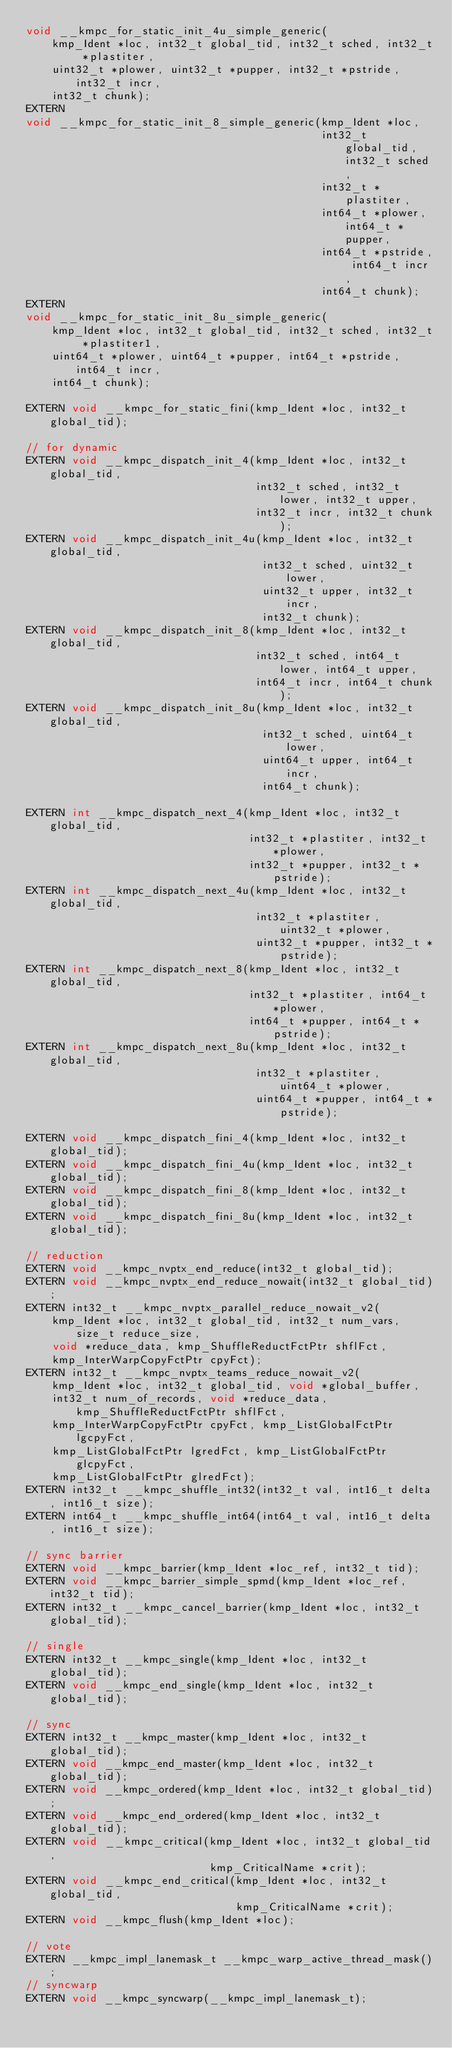<code> <loc_0><loc_0><loc_500><loc_500><_C_>void __kmpc_for_static_init_4u_simple_generic(
    kmp_Ident *loc, int32_t global_tid, int32_t sched, int32_t *plastiter,
    uint32_t *plower, uint32_t *pupper, int32_t *pstride, int32_t incr,
    int32_t chunk);
EXTERN
void __kmpc_for_static_init_8_simple_generic(kmp_Ident *loc,
                                             int32_t global_tid, int32_t sched,
                                             int32_t *plastiter,
                                             int64_t *plower, int64_t *pupper,
                                             int64_t *pstride, int64_t incr,
                                             int64_t chunk);
EXTERN
void __kmpc_for_static_init_8u_simple_generic(
    kmp_Ident *loc, int32_t global_tid, int32_t sched, int32_t *plastiter1,
    uint64_t *plower, uint64_t *pupper, int64_t *pstride, int64_t incr,
    int64_t chunk);

EXTERN void __kmpc_for_static_fini(kmp_Ident *loc, int32_t global_tid);

// for dynamic
EXTERN void __kmpc_dispatch_init_4(kmp_Ident *loc, int32_t global_tid,
                                   int32_t sched, int32_t lower, int32_t upper,
                                   int32_t incr, int32_t chunk);
EXTERN void __kmpc_dispatch_init_4u(kmp_Ident *loc, int32_t global_tid,
                                    int32_t sched, uint32_t lower,
                                    uint32_t upper, int32_t incr,
                                    int32_t chunk);
EXTERN void __kmpc_dispatch_init_8(kmp_Ident *loc, int32_t global_tid,
                                   int32_t sched, int64_t lower, int64_t upper,
                                   int64_t incr, int64_t chunk);
EXTERN void __kmpc_dispatch_init_8u(kmp_Ident *loc, int32_t global_tid,
                                    int32_t sched, uint64_t lower,
                                    uint64_t upper, int64_t incr,
                                    int64_t chunk);

EXTERN int __kmpc_dispatch_next_4(kmp_Ident *loc, int32_t global_tid,
                                  int32_t *plastiter, int32_t *plower,
                                  int32_t *pupper, int32_t *pstride);
EXTERN int __kmpc_dispatch_next_4u(kmp_Ident *loc, int32_t global_tid,
                                   int32_t *plastiter, uint32_t *plower,
                                   uint32_t *pupper, int32_t *pstride);
EXTERN int __kmpc_dispatch_next_8(kmp_Ident *loc, int32_t global_tid,
                                  int32_t *plastiter, int64_t *plower,
                                  int64_t *pupper, int64_t *pstride);
EXTERN int __kmpc_dispatch_next_8u(kmp_Ident *loc, int32_t global_tid,
                                   int32_t *plastiter, uint64_t *plower,
                                   uint64_t *pupper, int64_t *pstride);

EXTERN void __kmpc_dispatch_fini_4(kmp_Ident *loc, int32_t global_tid);
EXTERN void __kmpc_dispatch_fini_4u(kmp_Ident *loc, int32_t global_tid);
EXTERN void __kmpc_dispatch_fini_8(kmp_Ident *loc, int32_t global_tid);
EXTERN void __kmpc_dispatch_fini_8u(kmp_Ident *loc, int32_t global_tid);

// reduction
EXTERN void __kmpc_nvptx_end_reduce(int32_t global_tid);
EXTERN void __kmpc_nvptx_end_reduce_nowait(int32_t global_tid);
EXTERN int32_t __kmpc_nvptx_parallel_reduce_nowait_v2(
    kmp_Ident *loc, int32_t global_tid, int32_t num_vars, size_t reduce_size,
    void *reduce_data, kmp_ShuffleReductFctPtr shflFct,
    kmp_InterWarpCopyFctPtr cpyFct);
EXTERN int32_t __kmpc_nvptx_teams_reduce_nowait_v2(
    kmp_Ident *loc, int32_t global_tid, void *global_buffer,
    int32_t num_of_records, void *reduce_data, kmp_ShuffleReductFctPtr shflFct,
    kmp_InterWarpCopyFctPtr cpyFct, kmp_ListGlobalFctPtr lgcpyFct,
    kmp_ListGlobalFctPtr lgredFct, kmp_ListGlobalFctPtr glcpyFct,
    kmp_ListGlobalFctPtr glredFct);
EXTERN int32_t __kmpc_shuffle_int32(int32_t val, int16_t delta, int16_t size);
EXTERN int64_t __kmpc_shuffle_int64(int64_t val, int16_t delta, int16_t size);

// sync barrier
EXTERN void __kmpc_barrier(kmp_Ident *loc_ref, int32_t tid);
EXTERN void __kmpc_barrier_simple_spmd(kmp_Ident *loc_ref, int32_t tid);
EXTERN int32_t __kmpc_cancel_barrier(kmp_Ident *loc, int32_t global_tid);

// single
EXTERN int32_t __kmpc_single(kmp_Ident *loc, int32_t global_tid);
EXTERN void __kmpc_end_single(kmp_Ident *loc, int32_t global_tid);

// sync
EXTERN int32_t __kmpc_master(kmp_Ident *loc, int32_t global_tid);
EXTERN void __kmpc_end_master(kmp_Ident *loc, int32_t global_tid);
EXTERN void __kmpc_ordered(kmp_Ident *loc, int32_t global_tid);
EXTERN void __kmpc_end_ordered(kmp_Ident *loc, int32_t global_tid);
EXTERN void __kmpc_critical(kmp_Ident *loc, int32_t global_tid,
                            kmp_CriticalName *crit);
EXTERN void __kmpc_end_critical(kmp_Ident *loc, int32_t global_tid,
                                kmp_CriticalName *crit);
EXTERN void __kmpc_flush(kmp_Ident *loc);

// vote
EXTERN __kmpc_impl_lanemask_t __kmpc_warp_active_thread_mask();
// syncwarp
EXTERN void __kmpc_syncwarp(__kmpc_impl_lanemask_t);
</code> 